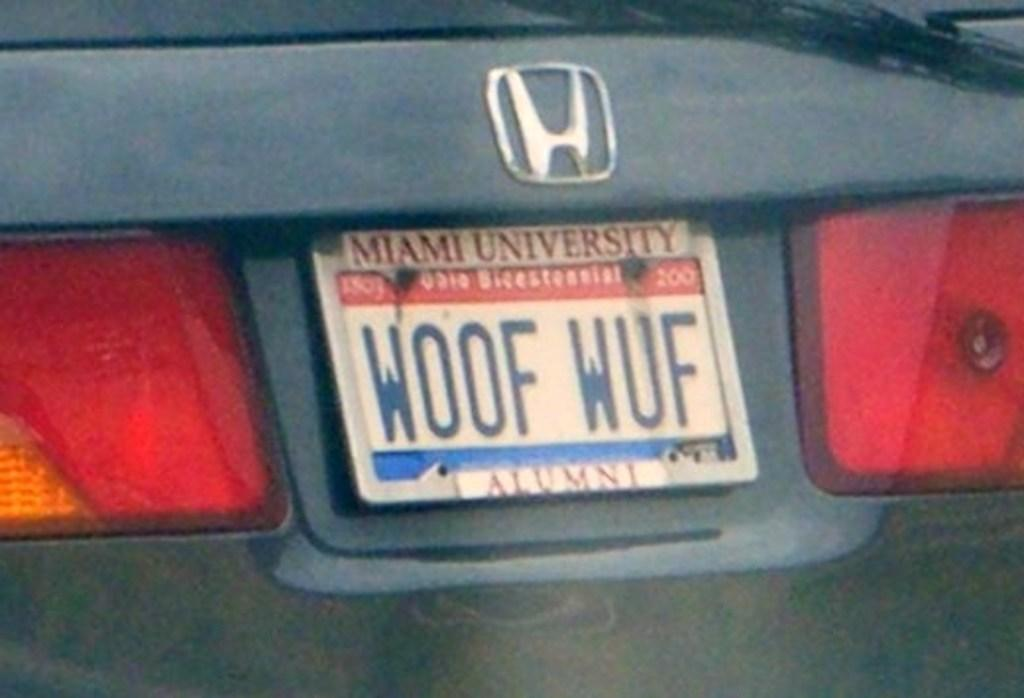<image>
Write a terse but informative summary of the picture. A car made by Honda has a license plate that says Woof Wuf. 